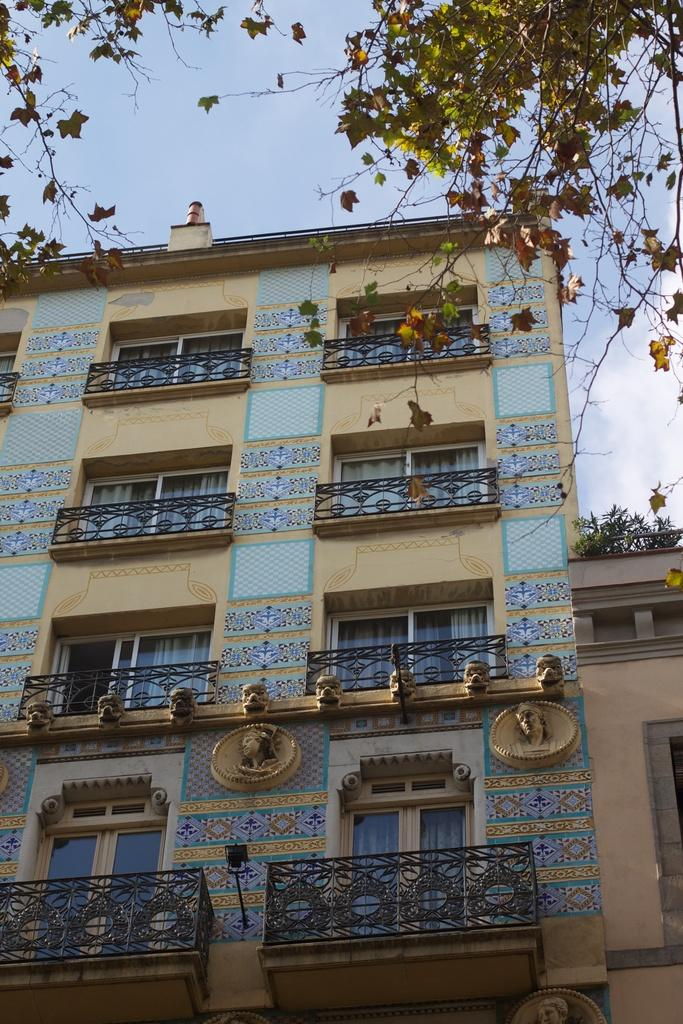What type of structures can be seen in the image? There are buildings in the image. What feature is present near the edge of the image? There is a railing in the image. What type of vegetation is visible in the image? There are plants and trees in the image. Are there any artistic elements on the buildings? Yes, there are sculptures on the buildings. What type of illumination is present in the image? There are lights in the image. What can be seen at the top of the image? The sky is visible at the top of the image. What type of toothbrush is being used to clean the sculptures in the image? There is no toothbrush present in the image, and the sculptures are not being cleaned. What emotion is being expressed by the trees in the image? Trees do not express emotions, and there is no indication of regret in the image. 